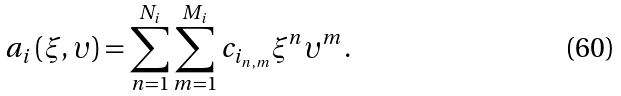Convert formula to latex. <formula><loc_0><loc_0><loc_500><loc_500>a _ { i } \left ( \xi , \upsilon \right ) = \sum _ { n = 1 } ^ { N _ { i } } \sum _ { m = 1 } ^ { M _ { i } } c _ { i _ { n , m } } \xi ^ { n } \upsilon ^ { m } .</formula> 